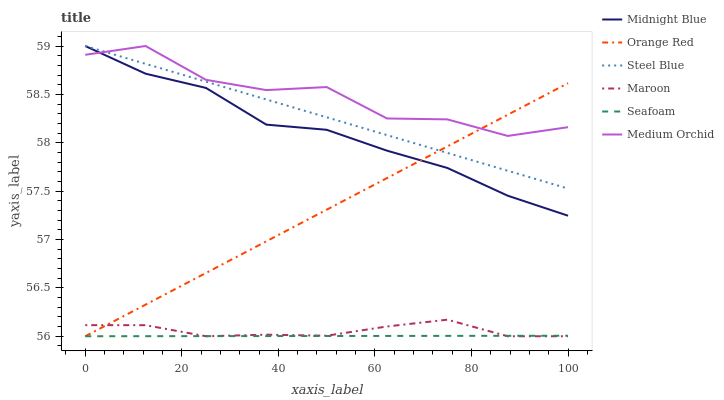Does Steel Blue have the minimum area under the curve?
Answer yes or no. No. Does Steel Blue have the maximum area under the curve?
Answer yes or no. No. Is Medium Orchid the smoothest?
Answer yes or no. No. Is Steel Blue the roughest?
Answer yes or no. No. Does Steel Blue have the lowest value?
Answer yes or no. No. Does Maroon have the highest value?
Answer yes or no. No. Is Maroon less than Medium Orchid?
Answer yes or no. Yes. Is Steel Blue greater than Seafoam?
Answer yes or no. Yes. Does Maroon intersect Medium Orchid?
Answer yes or no. No. 